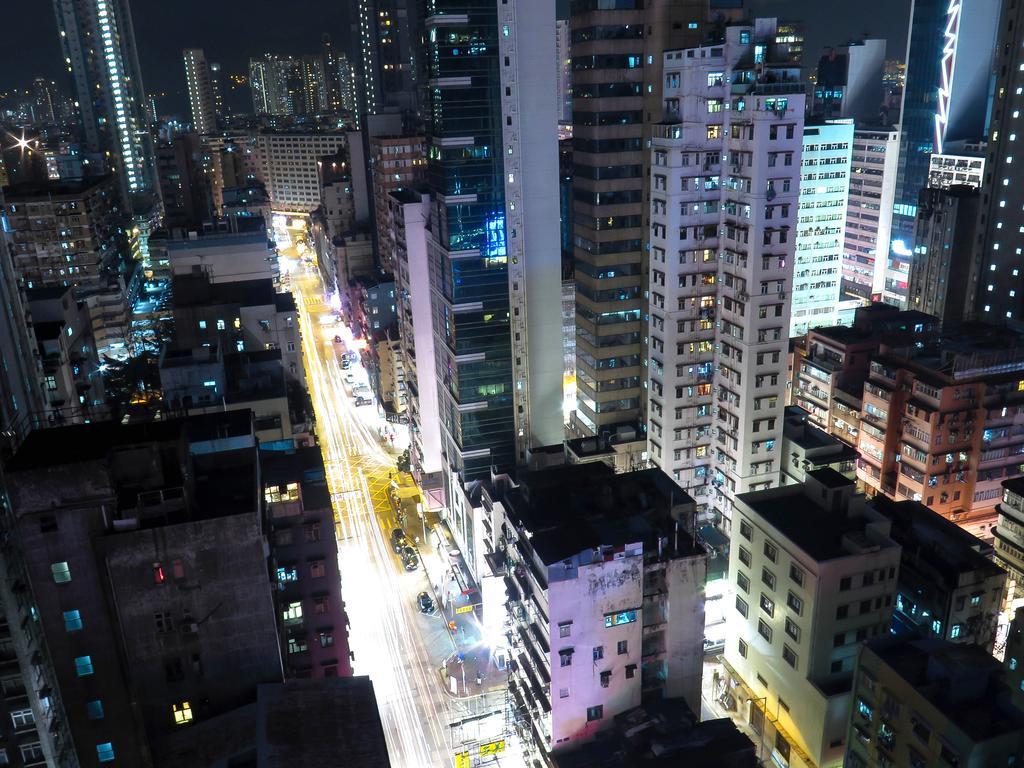Can you describe this image briefly? In the image we can see there are lot of buildings and there are cars parked on the road. 